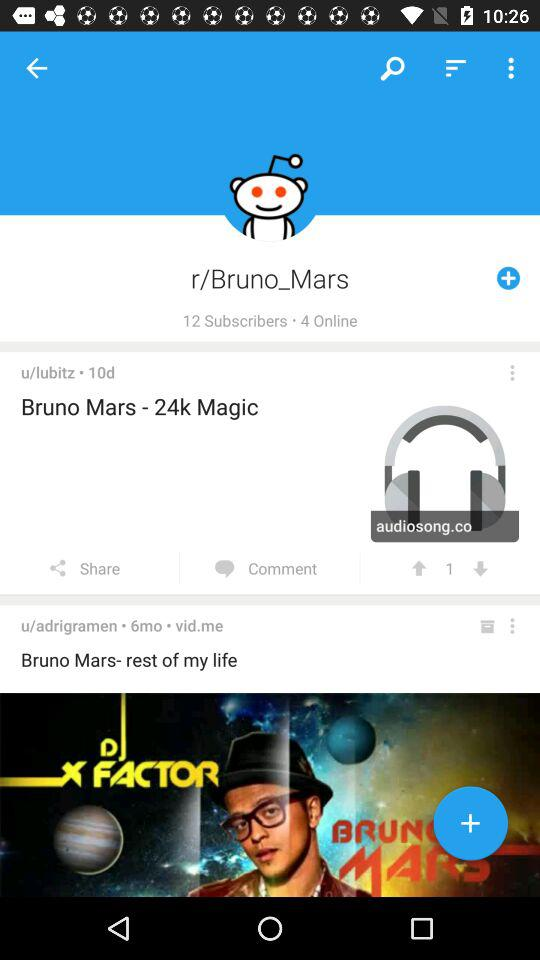What is the singer name? The singer name is Bruno Mars. 